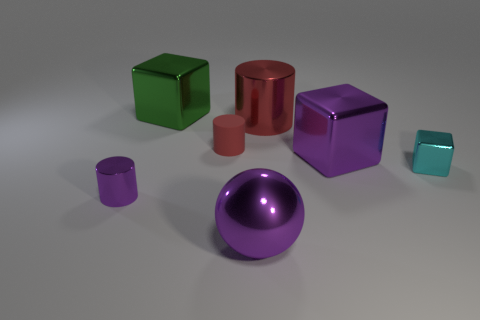The red cylinder to the left of the large object in front of the small cyan block is made of what material?
Your response must be concise. Rubber. What color is the sphere that is the same material as the big green object?
Your answer should be very brief. Purple. There is a small metallic object that is the same color as the large sphere; what is its shape?
Your answer should be compact. Cylinder. Does the purple shiny cube right of the large metallic cylinder have the same size as the shiny cylinder that is on the right side of the big green block?
Offer a terse response. Yes. What number of spheres are either tiny purple things or metal things?
Give a very brief answer. 1. Is the material of the purple thing that is to the left of the tiny red matte thing the same as the tiny red cylinder?
Your answer should be compact. No. How many other things are there of the same size as the red matte object?
Ensure brevity in your answer.  2. What number of large objects are purple metallic cubes or shiny cubes?
Keep it short and to the point. 2. Is the small shiny block the same color as the ball?
Provide a succinct answer. No. Are there more green metal cubes that are behind the green block than small purple things that are behind the purple cube?
Offer a very short reply. No. 